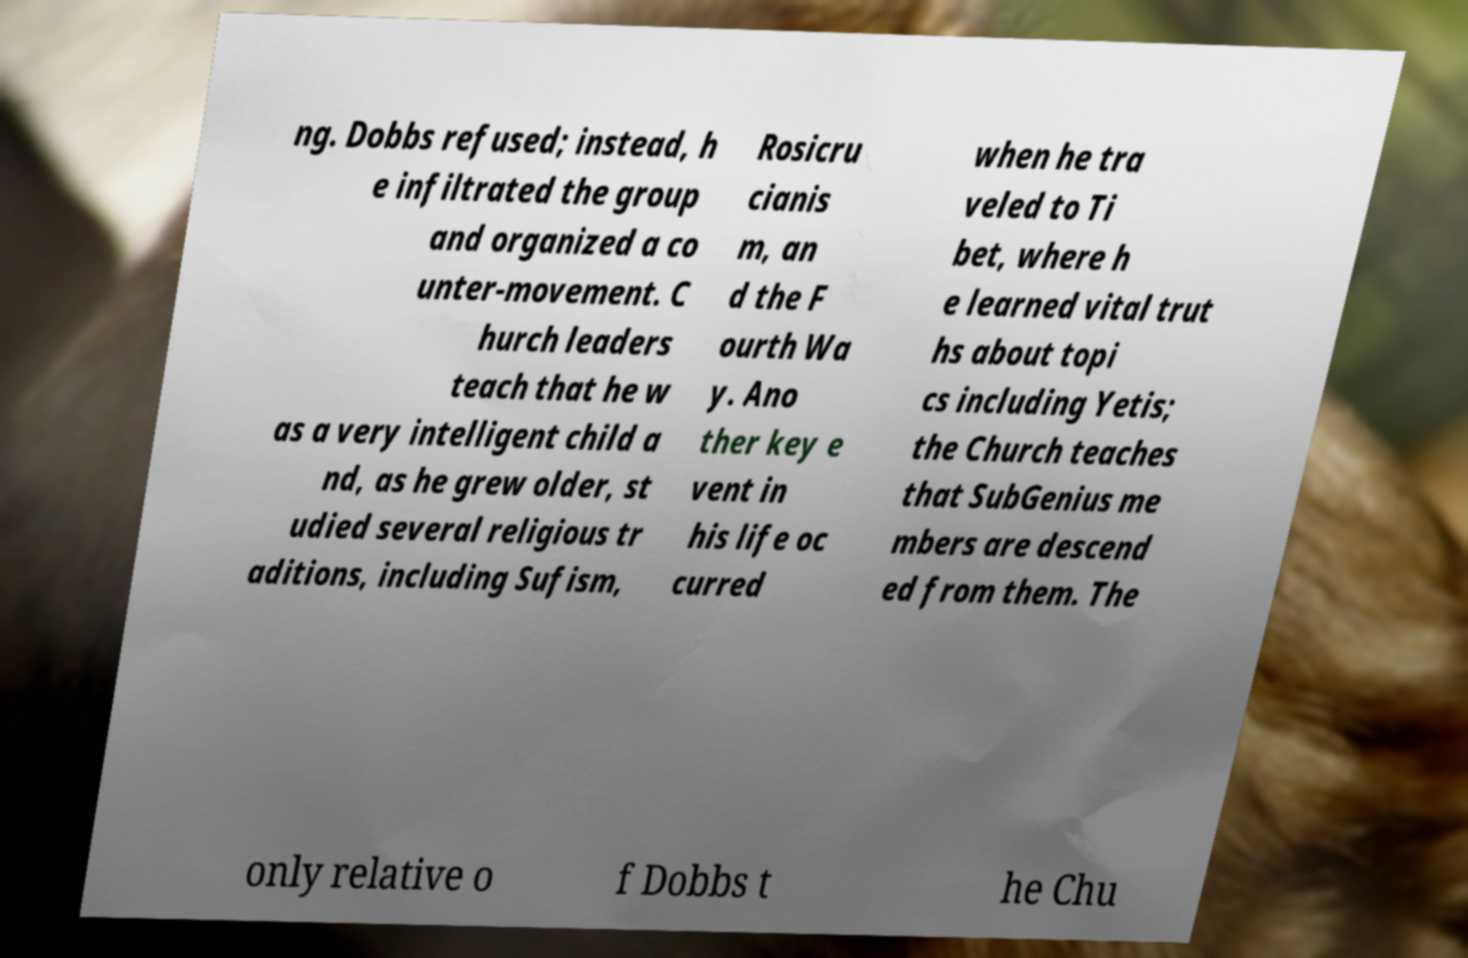Could you extract and type out the text from this image? ng. Dobbs refused; instead, h e infiltrated the group and organized a co unter-movement. C hurch leaders teach that he w as a very intelligent child a nd, as he grew older, st udied several religious tr aditions, including Sufism, Rosicru cianis m, an d the F ourth Wa y. Ano ther key e vent in his life oc curred when he tra veled to Ti bet, where h e learned vital trut hs about topi cs including Yetis; the Church teaches that SubGenius me mbers are descend ed from them. The only relative o f Dobbs t he Chu 